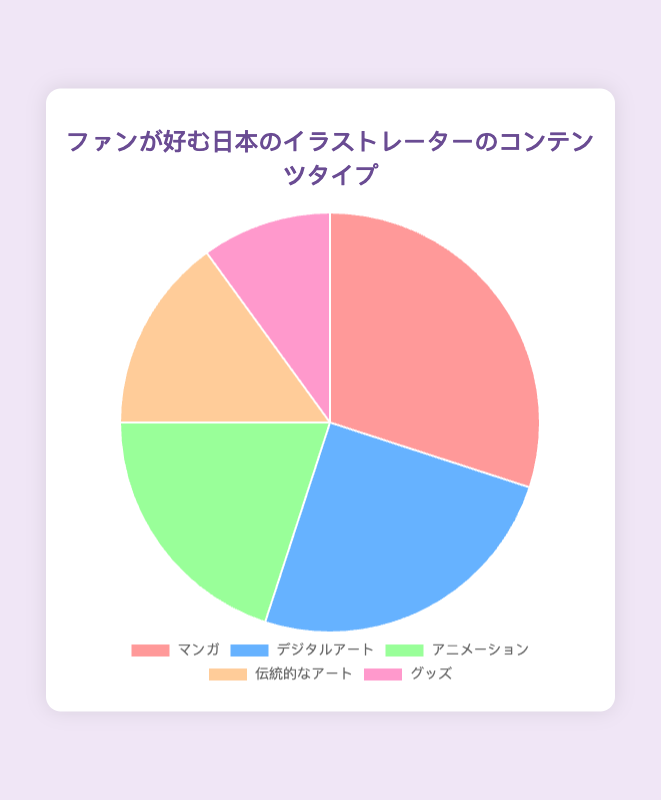What percentage of fans prefer digital artwork? Look at the segment labeled "デジタルアート" in the pie chart, which represents the digital artwork preference. The chart indicates that 25% of fans prefer digital artwork.
Answer: 25% Which is more popular, animations or traditional artwork? Compare the percentages of the segments labeled "アニメーション" and "伝統的なアート". Animations have a percentage of 20%, while traditional artwork has 15%. Therefore, animations are more popular.
Answer: Animations What is the combined percentage of fans who prefer manga and merchandise? Add the percentages of the segments labeled "マンガ" and "グッズ". Manga has 30% and merchandise has 10%. Therefore, 30% + 10% = 40%.
Answer: 40% Which content type is the least preferred? Identify the segment with the smallest percentage. The segment labeled "グッズ" (merchandise) has the lowest percentage at 10%.
Answer: Merchandise How much more popular is manga compared to traditional artwork? Subtract the percentage of traditional artwork from manga. Manga has 30% and traditional artwork has 15%. Therefore, 30% - 15% = 15%.
Answer: 15% What is the second most preferred content type? Look at the pie chart segments in descending order of their percentages. The first is manga (30%), and the second highest is digital artwork (25%).
Answer: Digital Artwork Which content types have a percentage that is above 20%? Identify segments with percentages greater than 20%. Manga has 30% and digital artwork has 25%, both are above 20%.
Answer: Manga, Digital Artwork What is the average preference percentage for all content types? Sum the percentages of all content types and divide by the number of content types. The percentages are 30, 25, 20, 15, and 10. Summing them gives 100. Dividing by 5 gives 100 / 5 = 20%.
Answer: 20% By what factor is manga more popular than merchandise? Divide the percentage of manga by the percentage of merchandise. Manga has 30% and merchandise has 10%, so 30 / 10 = 3.
Answer: 3 